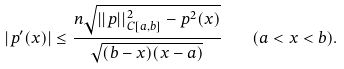Convert formula to latex. <formula><loc_0><loc_0><loc_500><loc_500>| p ^ { \prime } ( x ) | \leq \frac { n \sqrt { | | p | | _ { C [ a , b ] } ^ { 2 } - p ^ { 2 } ( { x } ) } } { \sqrt { ( b - x ) ( x - a ) } } \quad ( a < x < b ) .</formula> 